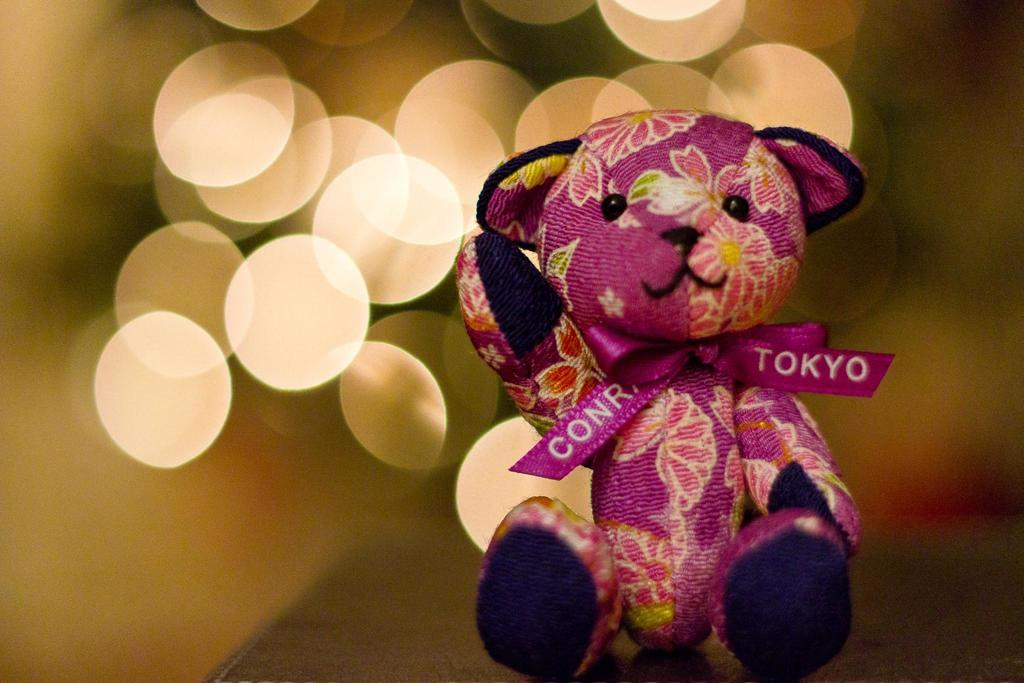What is the main subject of the image? The main subject of the image is a pink color toy. What is a noticeable feature of the toy? The toy has a pink color ribbon. How would you describe the background of the image? The background of the image is blurry. What position does the key hold in the image? There is no key present in the image. 